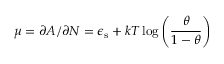Convert formula to latex. <formula><loc_0><loc_0><loc_500><loc_500>\mu = \partial A / \partial N = \epsilon _ { s } + k T \log \left ( \frac { \theta } { 1 - \theta } \right )</formula> 